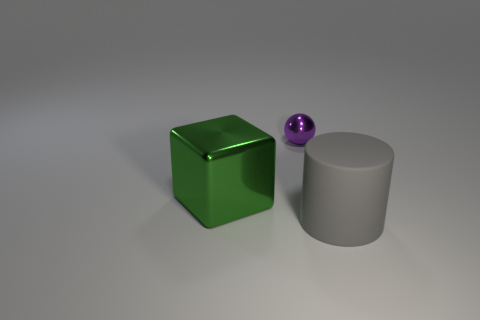There is a tiny purple ball; what number of big gray matte things are to the right of it?
Your answer should be very brief. 1. How big is the object that is in front of the big thing that is behind the thing to the right of the small metal thing?
Your response must be concise. Large. There is a metal thing on the right side of the large object that is to the left of the big cylinder; are there any cylinders that are to the left of it?
Provide a succinct answer. No. Is the number of large things greater than the number of things?
Offer a terse response. No. The large thing that is in front of the metal cube is what color?
Your response must be concise. Gray. Is the number of big matte cylinders that are to the right of the small purple ball greater than the number of small gray matte cylinders?
Your response must be concise. Yes. Do the tiny ball and the big cylinder have the same material?
Ensure brevity in your answer.  No. Is there anything else that has the same material as the large gray thing?
Your answer should be compact. No. There is a shiny object that is behind the shiny thing that is to the left of the metal thing right of the large green metal block; what is its color?
Make the answer very short. Purple. There is a large thing to the right of the sphere; is it the same shape as the large metal object?
Keep it short and to the point. No. 